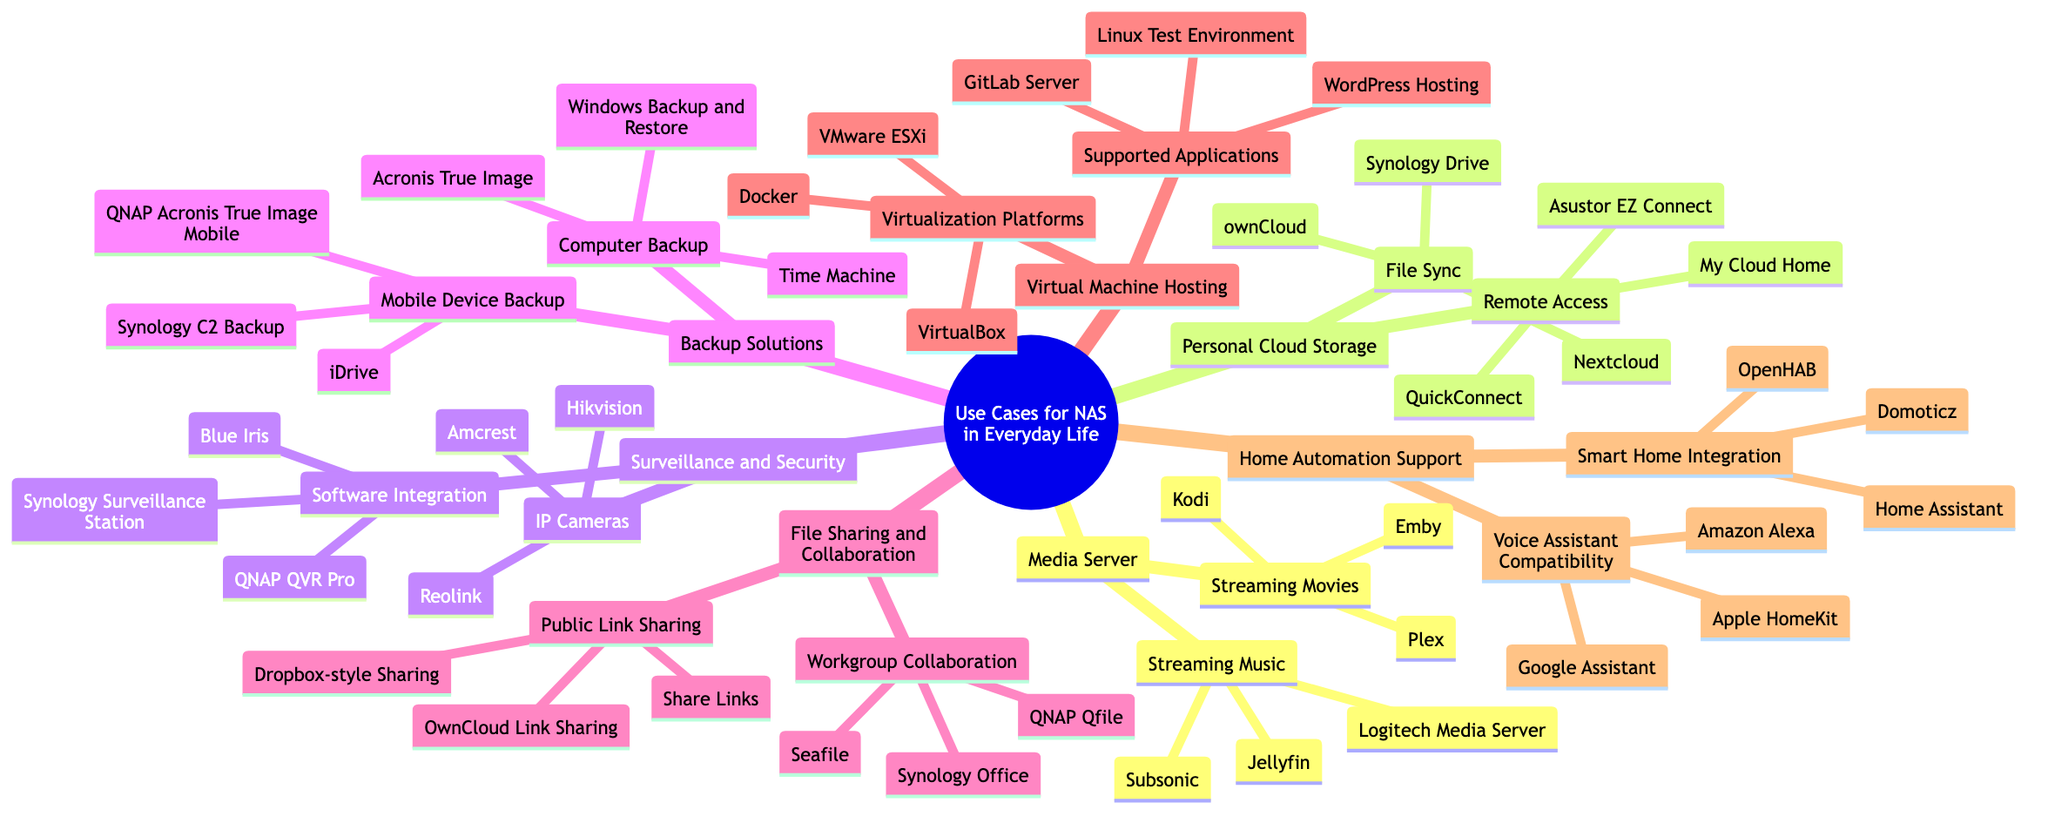What is one application for streaming movies listed in the diagram? The diagram lists multiple applications under "Streaming Movies." One of them is "Plex."
Answer: Plex How many nodes are under "Home Automation Support"? Under "Home Automation Support," there are two main nodes: "Smart Home Integration" and "Voice Assistant Compatibility," making a total of two nodes.
Answer: 2 What type of backup solutions can be used for mobile devices? The diagram mentions three specific solutions for mobile device backup, which are "Synology C2 Backup," "QNAP Acronis True Image Mobile," and "iDrive."
Answer: Synology C2 Backup Which section includes support for virtualization platforms? "Virtual Machine Hosting" is the section that includes various virtualization platforms like "Docker," "VMware ESXi," and "VirtualBox."
Answer: Virtual Machine Hosting Are there more applications for "Streaming Music" or "Streaming Movies"? In "Streaming Music," there are three applications listed, while "Streaming Movies" also has three applications; therefore, they are equal in number.
Answer: Equal What is an example of software integration for surveillance? The diagram cites "Synology Surveillance Station" as an example of software integration for surveillance and security systems.
Answer: Synology Surveillance Station Which application is related to "File Sync" in Personal Cloud Storage? "Synology Drive" is cited as one of the applications related to "File Sync" under "Personal Cloud Storage."
Answer: Synology Drive What is a common feature between "File Sharing and Collaboration" and "Personal Cloud Storage"? Both sections provide options for sharing and accessing files, making them integral to teamwork and data accessibility.
Answer: File sharing How many applications are listed under "Backup Solutions" for computer backup? There are three applications listed for computer backup: "Time Machine," "Acronis True Image," and "Windows Backup and Restore."
Answer: 3 